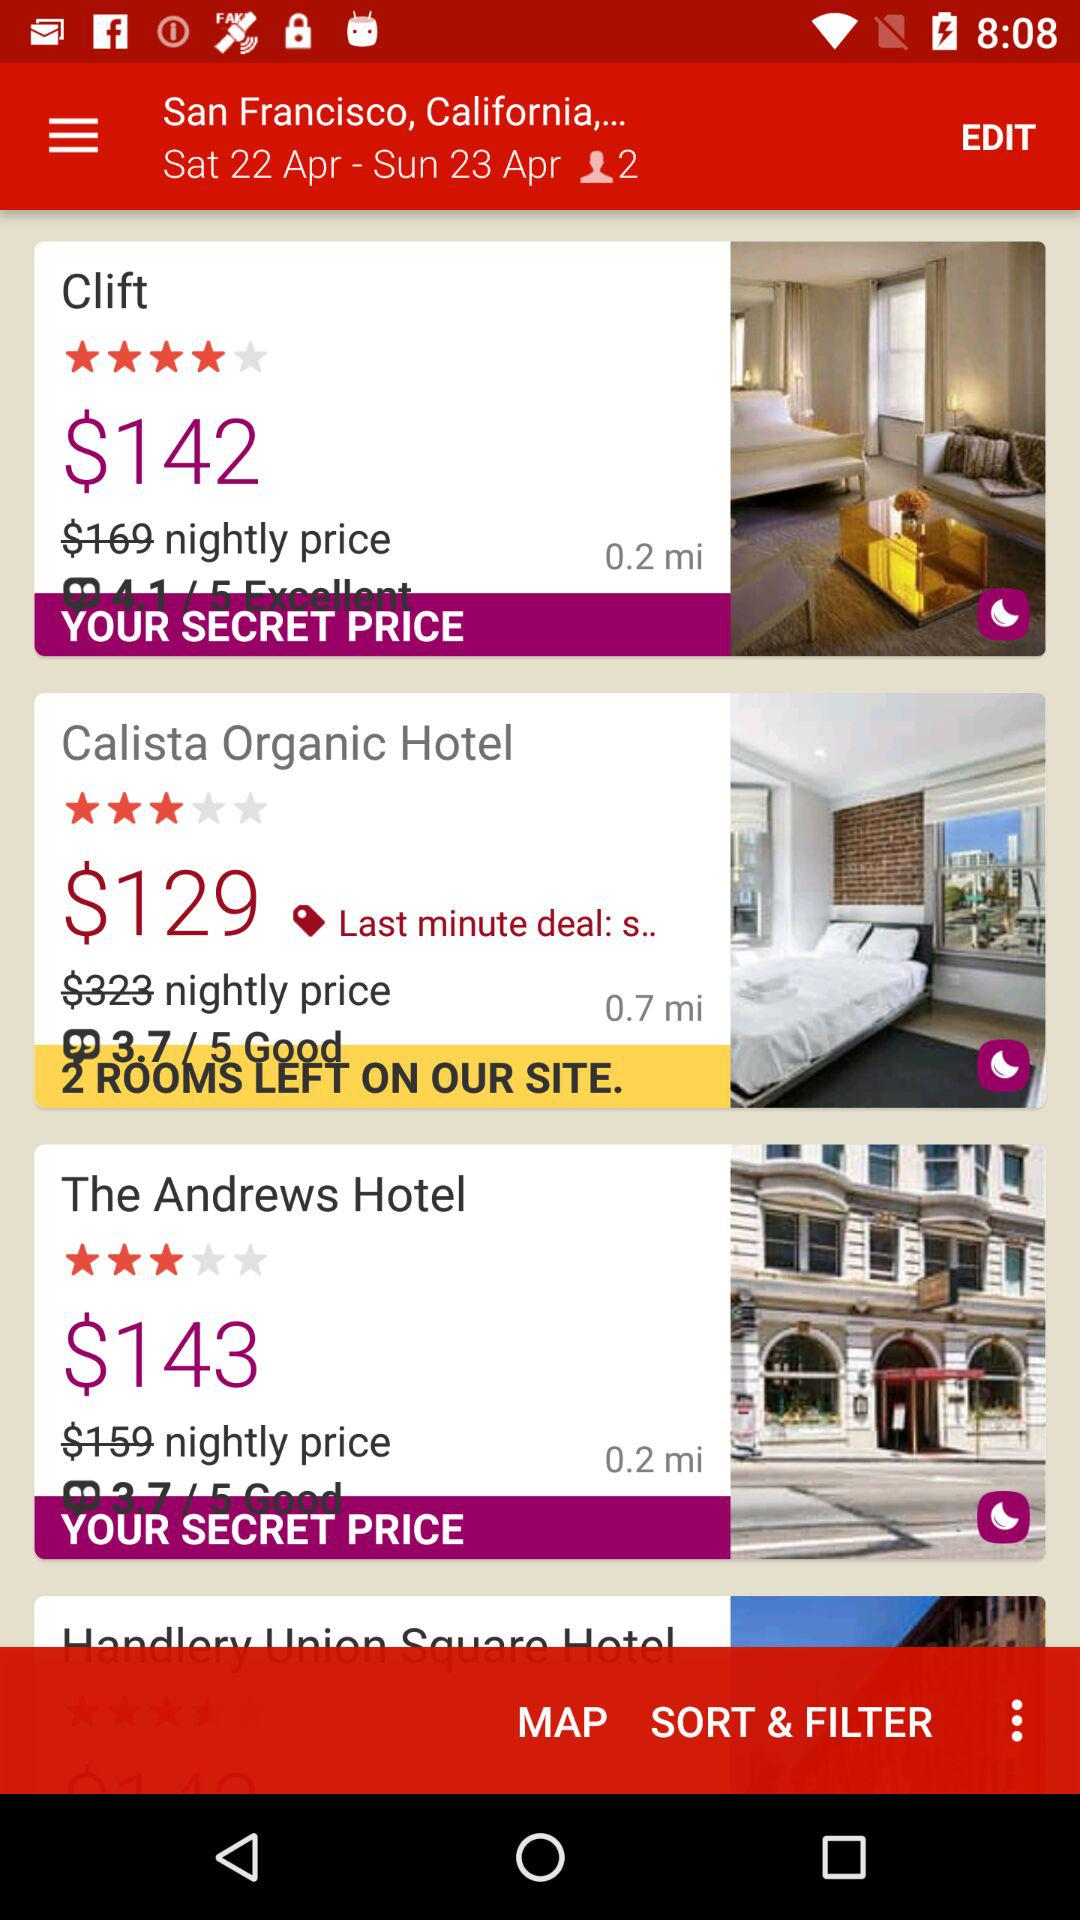What is the mentioned location? The mentioned location is "San Francisco, California,...". 